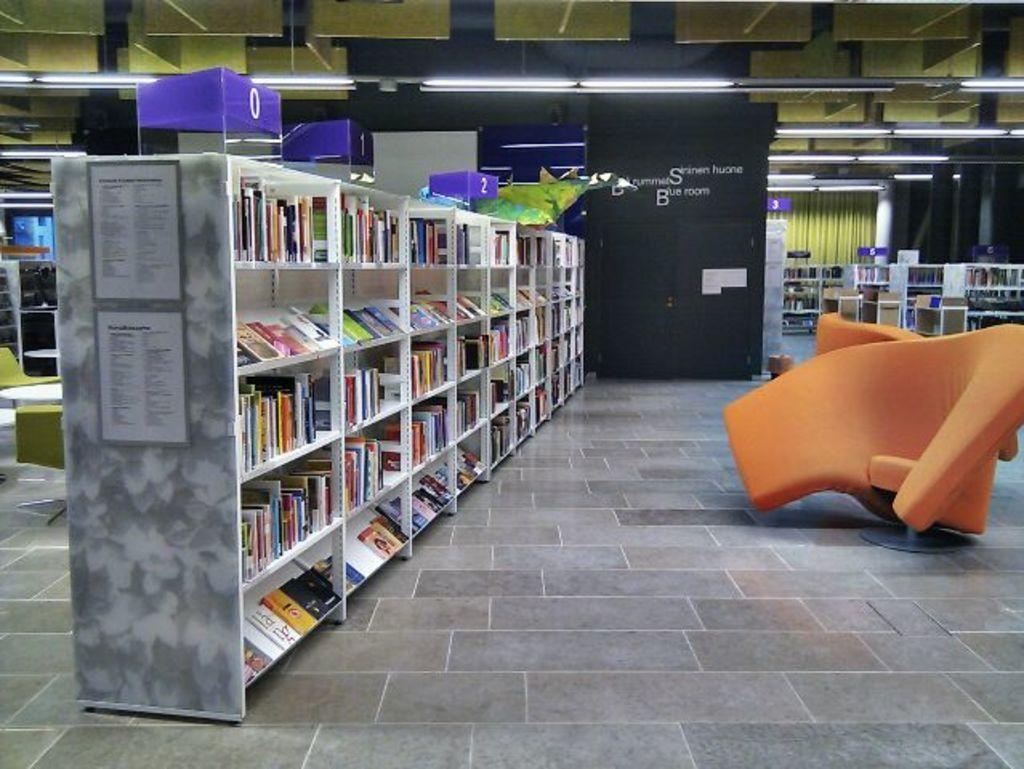What type of space is depicted in the image? The image shows an inner view of a hall. What furniture can be seen in the hall? There are chairs and book shelves with books in the hall. Are there any lighting fixtures in the hall? Yes, there are lights in the hall. What other furniture is present in the hall besides chairs and book shelves? There are additional chairs and tables in the hall. How many cattle are present in the hall in the image? There are no cattle present in the hall in the image. 